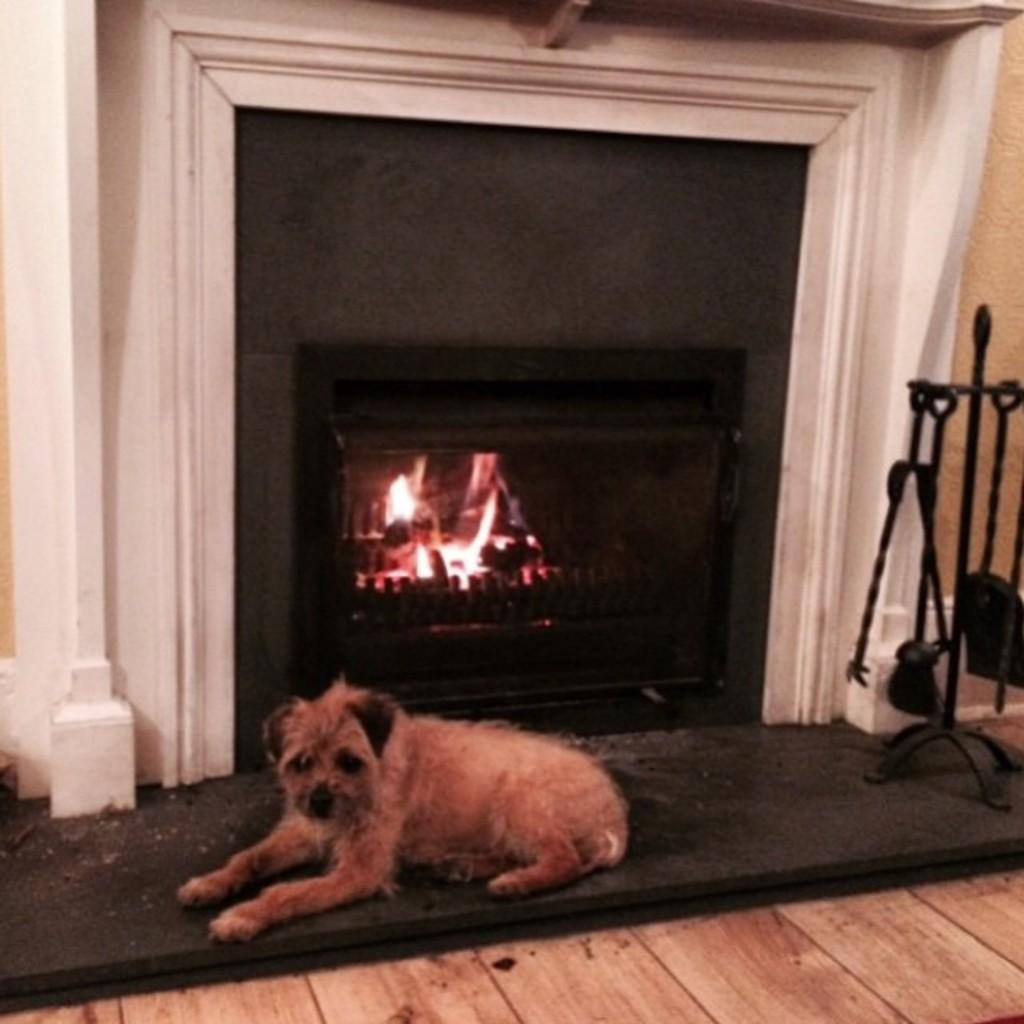What animal is sitting near the fireplace in the image? There is a dog sitting near the fireplace in the image. What object can be seen on the stand on the right side? There is a spade on the stand on the right side. What type of flooring is visible in the image? The floor is wooden. What type of paper does the dog use to roll around in the image? There is no paper present in the image, and the dog is not rolling around. 